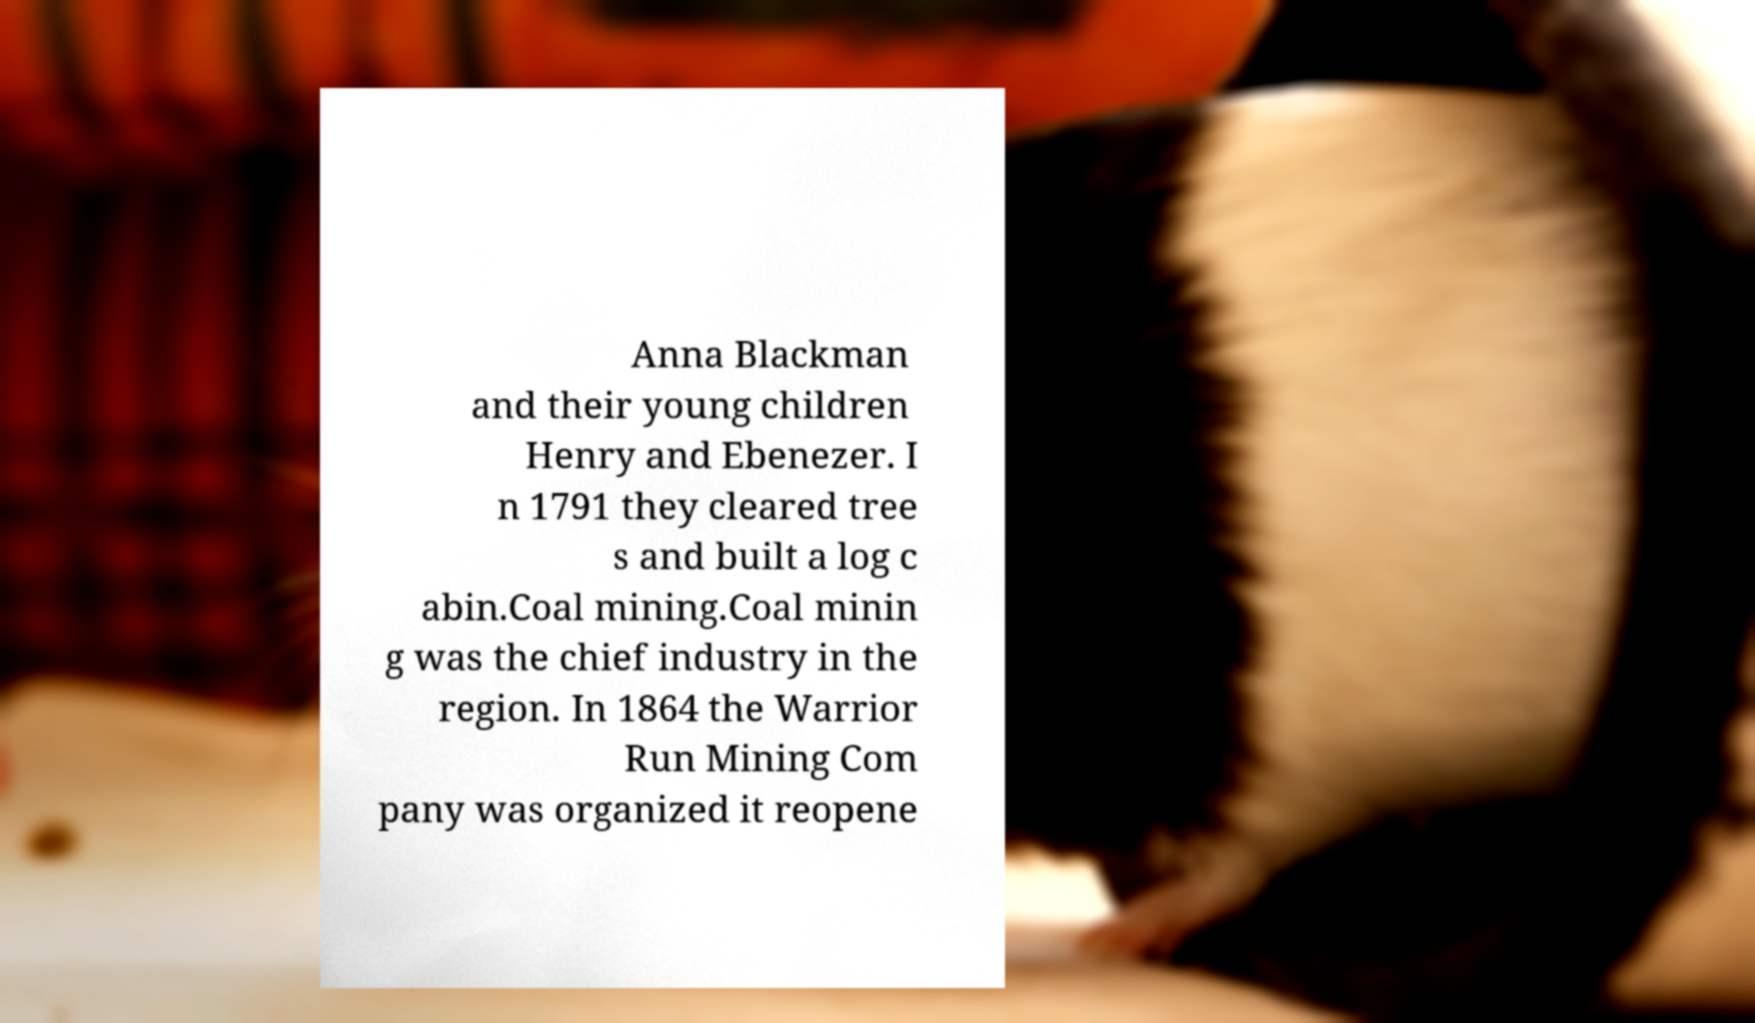Could you assist in decoding the text presented in this image and type it out clearly? Anna Blackman and their young children Henry and Ebenezer. I n 1791 they cleared tree s and built a log c abin.Coal mining.Coal minin g was the chief industry in the region. In 1864 the Warrior Run Mining Com pany was organized it reopene 